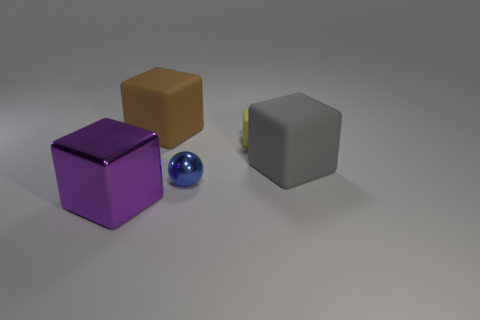Are there the same number of yellow rubber things behind the yellow block and gray cubes in front of the blue thing?
Provide a succinct answer. Yes. There is a thing in front of the metal object behind the big purple metallic thing; what shape is it?
Your answer should be very brief. Cube. There is a large purple object that is the same shape as the yellow object; what material is it?
Provide a short and direct response. Metal. The ball that is the same size as the yellow cube is what color?
Your answer should be compact. Blue. Is the number of large matte things that are to the left of the metal block the same as the number of small yellow cubes?
Your answer should be very brief. No. The big block that is in front of the matte object that is right of the tiny yellow object is what color?
Give a very brief answer. Purple. There is a purple metallic object that is left of the large block that is on the right side of the blue ball; how big is it?
Make the answer very short. Large. What number of other things are there of the same size as the yellow block?
Ensure brevity in your answer.  1. What is the color of the shiny object that is behind the block that is in front of the large rubber thing that is right of the small matte cube?
Your answer should be compact. Blue. How many other things are there of the same shape as the purple object?
Your answer should be compact. 3. 